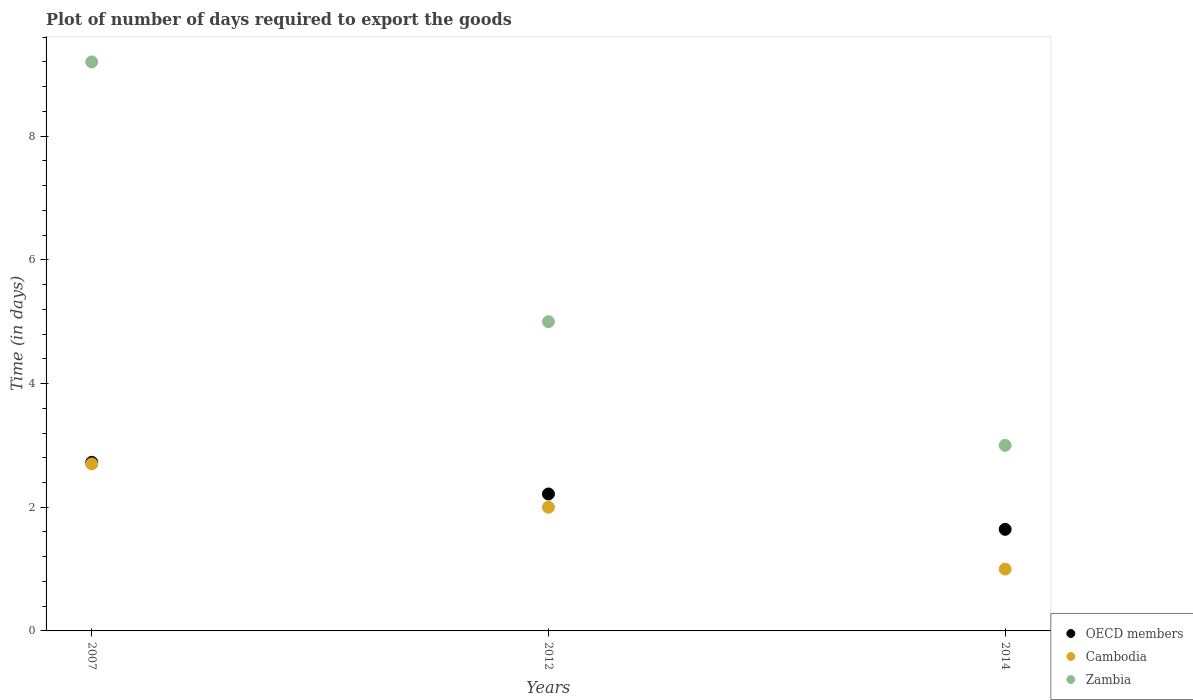Is the number of dotlines equal to the number of legend labels?
Offer a terse response. Yes. Across all years, what is the maximum time required to export goods in Cambodia?
Your response must be concise. 2.7. Across all years, what is the minimum time required to export goods in OECD members?
Keep it short and to the point. 1.64. In which year was the time required to export goods in Zambia maximum?
Offer a terse response. 2007. In which year was the time required to export goods in Cambodia minimum?
Make the answer very short. 2014. What is the total time required to export goods in OECD members in the graph?
Give a very brief answer. 6.58. What is the difference between the time required to export goods in OECD members in 2007 and that in 2012?
Your answer should be compact. 0.51. What is the difference between the time required to export goods in OECD members in 2014 and the time required to export goods in Zambia in 2012?
Offer a terse response. -3.36. What is the average time required to export goods in Cambodia per year?
Your answer should be compact. 1.9. In the year 2014, what is the difference between the time required to export goods in Zambia and time required to export goods in OECD members?
Make the answer very short. 1.36. In how many years, is the time required to export goods in OECD members greater than 0.8 days?
Ensure brevity in your answer.  3. What is the ratio of the time required to export goods in Zambia in 2007 to that in 2012?
Make the answer very short. 1.84. Is the time required to export goods in OECD members in 2007 less than that in 2014?
Make the answer very short. No. What is the difference between the highest and the second highest time required to export goods in Cambodia?
Your answer should be very brief. 0.7. What is the difference between the highest and the lowest time required to export goods in Cambodia?
Your response must be concise. 1.7. In how many years, is the time required to export goods in Zambia greater than the average time required to export goods in Zambia taken over all years?
Provide a succinct answer. 1. Is the sum of the time required to export goods in Cambodia in 2007 and 2012 greater than the maximum time required to export goods in OECD members across all years?
Offer a very short reply. Yes. Is it the case that in every year, the sum of the time required to export goods in Zambia and time required to export goods in OECD members  is greater than the time required to export goods in Cambodia?
Make the answer very short. Yes. Does the time required to export goods in Cambodia monotonically increase over the years?
Your answer should be compact. No. Is the time required to export goods in OECD members strictly greater than the time required to export goods in Zambia over the years?
Your answer should be very brief. No. Is the time required to export goods in Cambodia strictly less than the time required to export goods in OECD members over the years?
Give a very brief answer. Yes. How many dotlines are there?
Ensure brevity in your answer.  3. Does the graph contain any zero values?
Ensure brevity in your answer.  No. Does the graph contain grids?
Ensure brevity in your answer.  No. What is the title of the graph?
Ensure brevity in your answer.  Plot of number of days required to export the goods. Does "Mauritius" appear as one of the legend labels in the graph?
Make the answer very short. No. What is the label or title of the Y-axis?
Provide a succinct answer. Time (in days). What is the Time (in days) of OECD members in 2007?
Your response must be concise. 2.73. What is the Time (in days) in Cambodia in 2007?
Keep it short and to the point. 2.7. What is the Time (in days) of OECD members in 2012?
Offer a very short reply. 2.21. What is the Time (in days) in Cambodia in 2012?
Your answer should be compact. 2. What is the Time (in days) of OECD members in 2014?
Make the answer very short. 1.64. What is the Time (in days) of Cambodia in 2014?
Your response must be concise. 1. Across all years, what is the maximum Time (in days) in OECD members?
Provide a succinct answer. 2.73. Across all years, what is the maximum Time (in days) in Cambodia?
Keep it short and to the point. 2.7. Across all years, what is the maximum Time (in days) of Zambia?
Give a very brief answer. 9.2. Across all years, what is the minimum Time (in days) in OECD members?
Give a very brief answer. 1.64. Across all years, what is the minimum Time (in days) of Zambia?
Make the answer very short. 3. What is the total Time (in days) of OECD members in the graph?
Give a very brief answer. 6.58. What is the total Time (in days) in Cambodia in the graph?
Offer a terse response. 5.7. What is the total Time (in days) in Zambia in the graph?
Make the answer very short. 17.2. What is the difference between the Time (in days) in OECD members in 2007 and that in 2012?
Your answer should be very brief. 0.51. What is the difference between the Time (in days) in Cambodia in 2007 and that in 2012?
Keep it short and to the point. 0.7. What is the difference between the Time (in days) of Zambia in 2007 and that in 2012?
Your response must be concise. 4.2. What is the difference between the Time (in days) in OECD members in 2007 and that in 2014?
Keep it short and to the point. 1.08. What is the difference between the Time (in days) of OECD members in 2012 and that in 2014?
Your answer should be very brief. 0.57. What is the difference between the Time (in days) in Cambodia in 2012 and that in 2014?
Ensure brevity in your answer.  1. What is the difference between the Time (in days) of Zambia in 2012 and that in 2014?
Ensure brevity in your answer.  2. What is the difference between the Time (in days) of OECD members in 2007 and the Time (in days) of Cambodia in 2012?
Offer a terse response. 0.73. What is the difference between the Time (in days) in OECD members in 2007 and the Time (in days) in Zambia in 2012?
Provide a succinct answer. -2.27. What is the difference between the Time (in days) of Cambodia in 2007 and the Time (in days) of Zambia in 2012?
Your answer should be compact. -2.3. What is the difference between the Time (in days) of OECD members in 2007 and the Time (in days) of Cambodia in 2014?
Your answer should be very brief. 1.73. What is the difference between the Time (in days) of OECD members in 2007 and the Time (in days) of Zambia in 2014?
Your answer should be very brief. -0.27. What is the difference between the Time (in days) in OECD members in 2012 and the Time (in days) in Cambodia in 2014?
Keep it short and to the point. 1.21. What is the difference between the Time (in days) in OECD members in 2012 and the Time (in days) in Zambia in 2014?
Provide a succinct answer. -0.79. What is the average Time (in days) of OECD members per year?
Your answer should be very brief. 2.19. What is the average Time (in days) in Zambia per year?
Ensure brevity in your answer.  5.73. In the year 2007, what is the difference between the Time (in days) of OECD members and Time (in days) of Cambodia?
Keep it short and to the point. 0.03. In the year 2007, what is the difference between the Time (in days) of OECD members and Time (in days) of Zambia?
Offer a very short reply. -6.47. In the year 2012, what is the difference between the Time (in days) of OECD members and Time (in days) of Cambodia?
Provide a short and direct response. 0.21. In the year 2012, what is the difference between the Time (in days) of OECD members and Time (in days) of Zambia?
Ensure brevity in your answer.  -2.79. In the year 2012, what is the difference between the Time (in days) in Cambodia and Time (in days) in Zambia?
Your response must be concise. -3. In the year 2014, what is the difference between the Time (in days) in OECD members and Time (in days) in Cambodia?
Offer a terse response. 0.64. In the year 2014, what is the difference between the Time (in days) in OECD members and Time (in days) in Zambia?
Offer a terse response. -1.36. In the year 2014, what is the difference between the Time (in days) in Cambodia and Time (in days) in Zambia?
Provide a succinct answer. -2. What is the ratio of the Time (in days) in OECD members in 2007 to that in 2012?
Your answer should be very brief. 1.23. What is the ratio of the Time (in days) of Cambodia in 2007 to that in 2012?
Make the answer very short. 1.35. What is the ratio of the Time (in days) in Zambia in 2007 to that in 2012?
Give a very brief answer. 1.84. What is the ratio of the Time (in days) of OECD members in 2007 to that in 2014?
Your response must be concise. 1.66. What is the ratio of the Time (in days) in Cambodia in 2007 to that in 2014?
Your response must be concise. 2.7. What is the ratio of the Time (in days) of Zambia in 2007 to that in 2014?
Ensure brevity in your answer.  3.07. What is the ratio of the Time (in days) of OECD members in 2012 to that in 2014?
Provide a succinct answer. 1.35. What is the difference between the highest and the second highest Time (in days) of OECD members?
Ensure brevity in your answer.  0.51. What is the difference between the highest and the lowest Time (in days) in OECD members?
Give a very brief answer. 1.08. What is the difference between the highest and the lowest Time (in days) of Cambodia?
Give a very brief answer. 1.7. What is the difference between the highest and the lowest Time (in days) in Zambia?
Offer a very short reply. 6.2. 